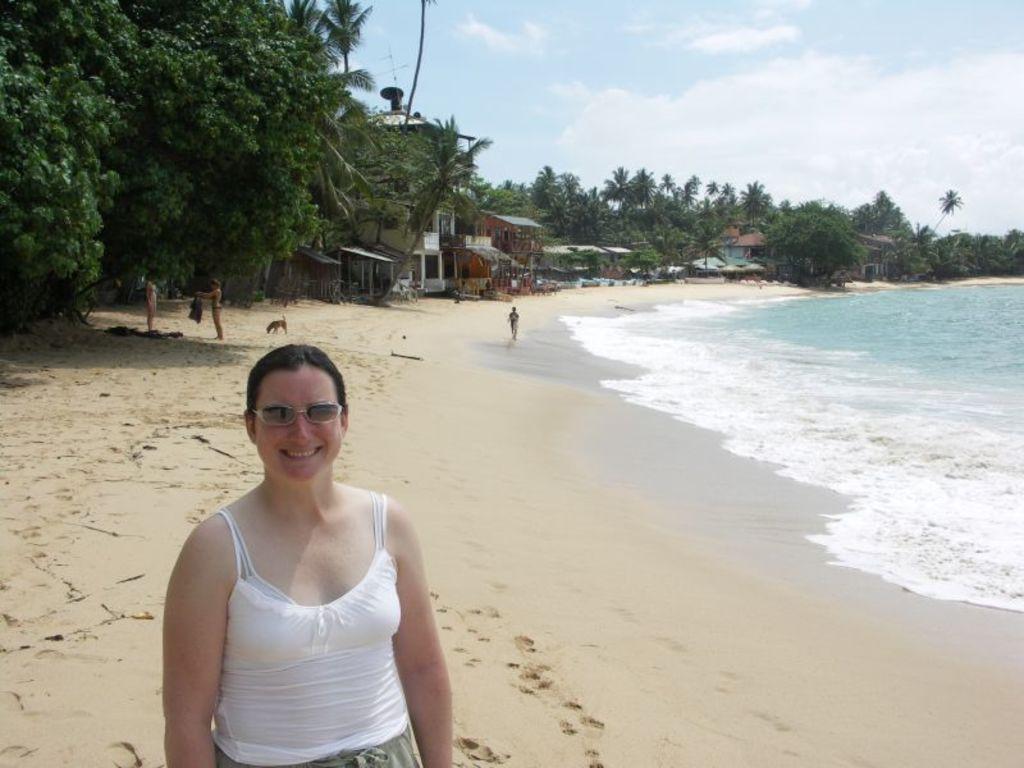How would you summarize this image in a sentence or two? In this picture, I can see certain trees and small huts and four people which includes with a dog and i can see foot prints on the ground and beach, water. 